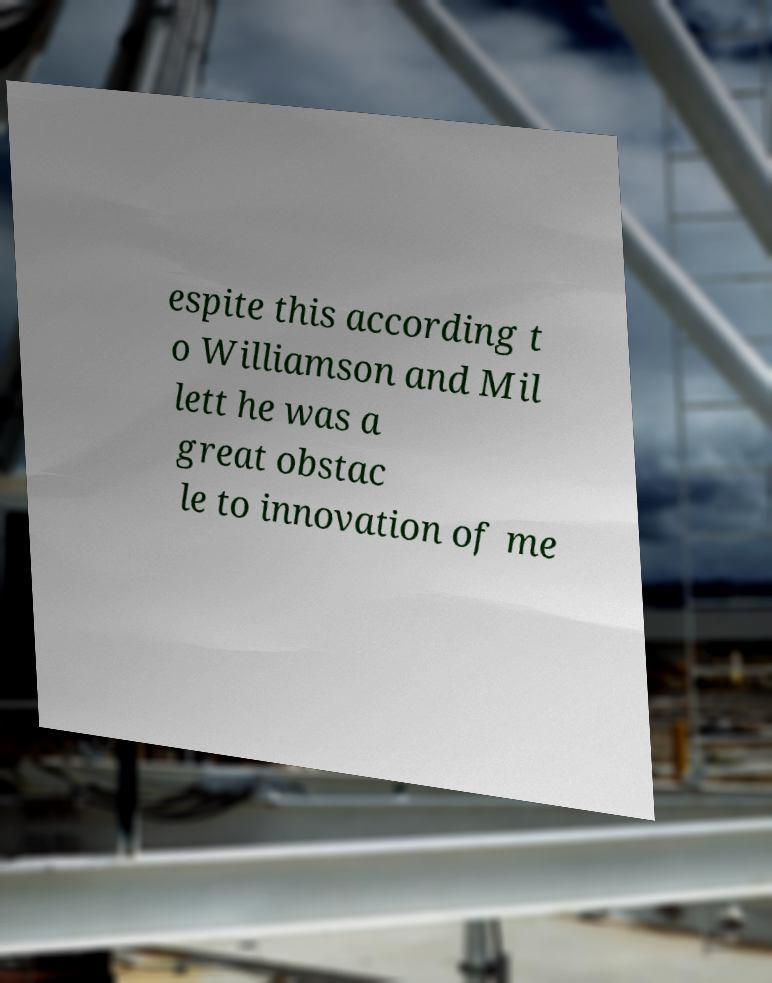Can you read and provide the text displayed in the image?This photo seems to have some interesting text. Can you extract and type it out for me? espite this according t o Williamson and Mil lett he was a great obstac le to innovation of me 